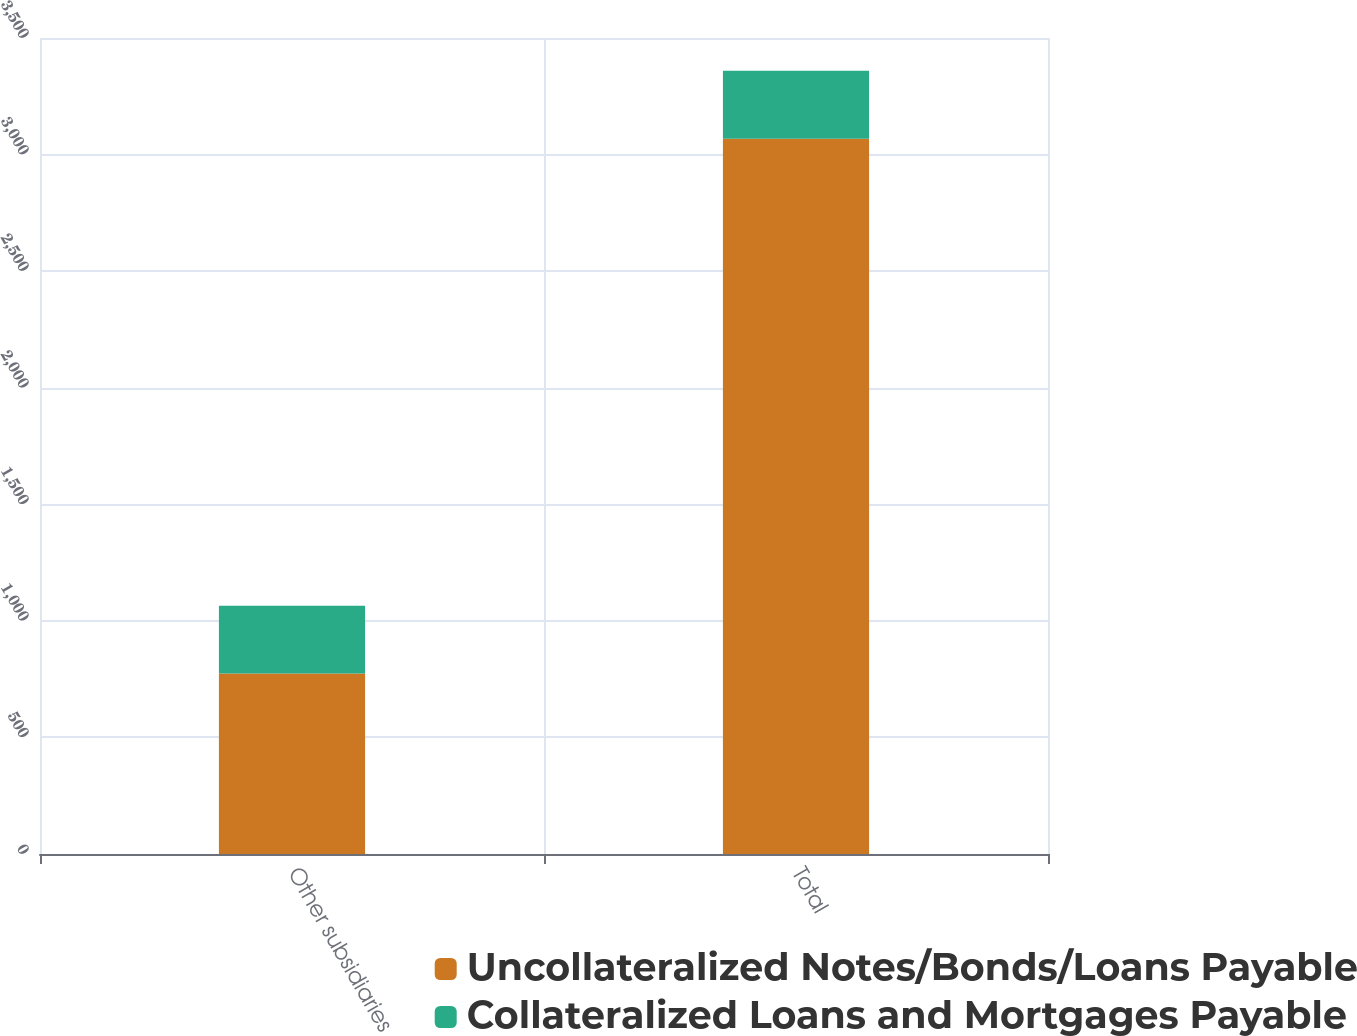Convert chart to OTSL. <chart><loc_0><loc_0><loc_500><loc_500><stacked_bar_chart><ecel><fcel>Other subsidiaries<fcel>Total<nl><fcel>Uncollateralized Notes/Bonds/Loans Payable<fcel>774<fcel>3068<nl><fcel>Collateralized Loans and Mortgages Payable<fcel>291<fcel>291<nl></chart> 